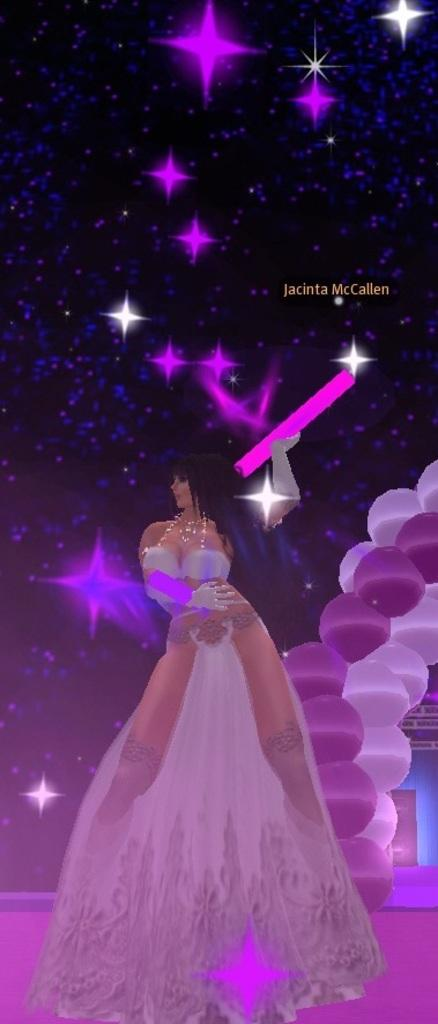What is the main subject of the image? There is a woman standing in the image. What is the woman standing on? The woman is standing on the floor. What can be seen at the back side of the image? There are balloons at the back side of the image. What is visible in the sky at the top of the image? There are stars visible in the sky at the top of the image. What type of produce is the woman holding in the image? There is no produce visible in the image; the woman is not holding any fruits or vegetables. 